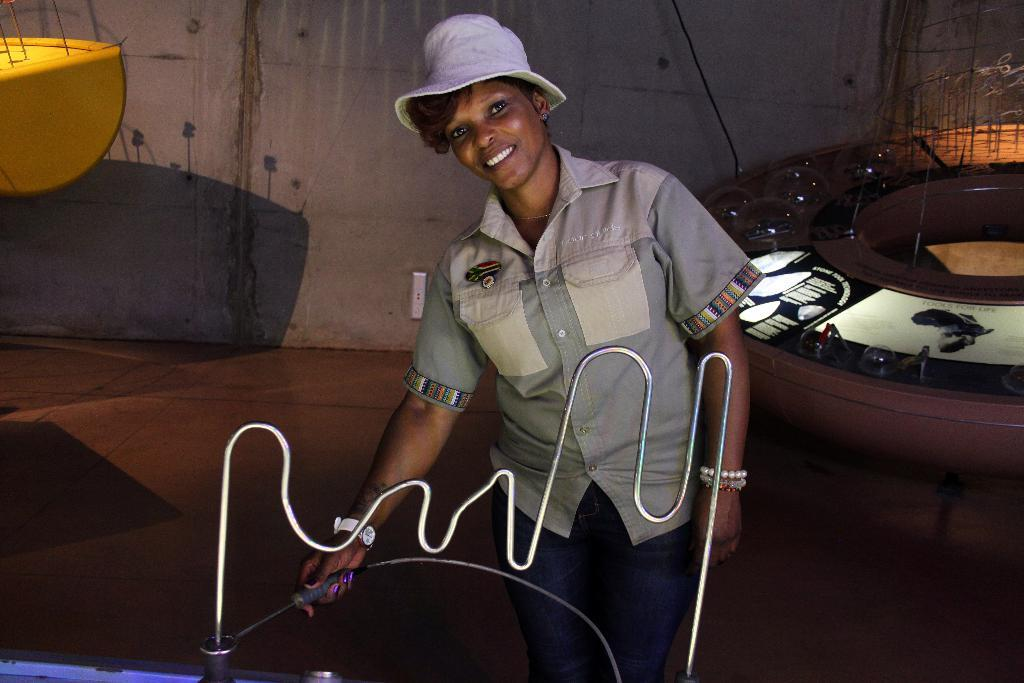Who is the main subject in the image? There is a lady in the image. Where is the lady positioned in the image? The lady is in the center of the image. What is the lady holding in her hand? The lady is holding a metal stick in her hand. What type of veil is covering the lady's face in the image? There is no veil covering the lady's face in the image; she is holding a metal stick. How does the engine contribute to the scene in the image? There is no engine present in the image. 